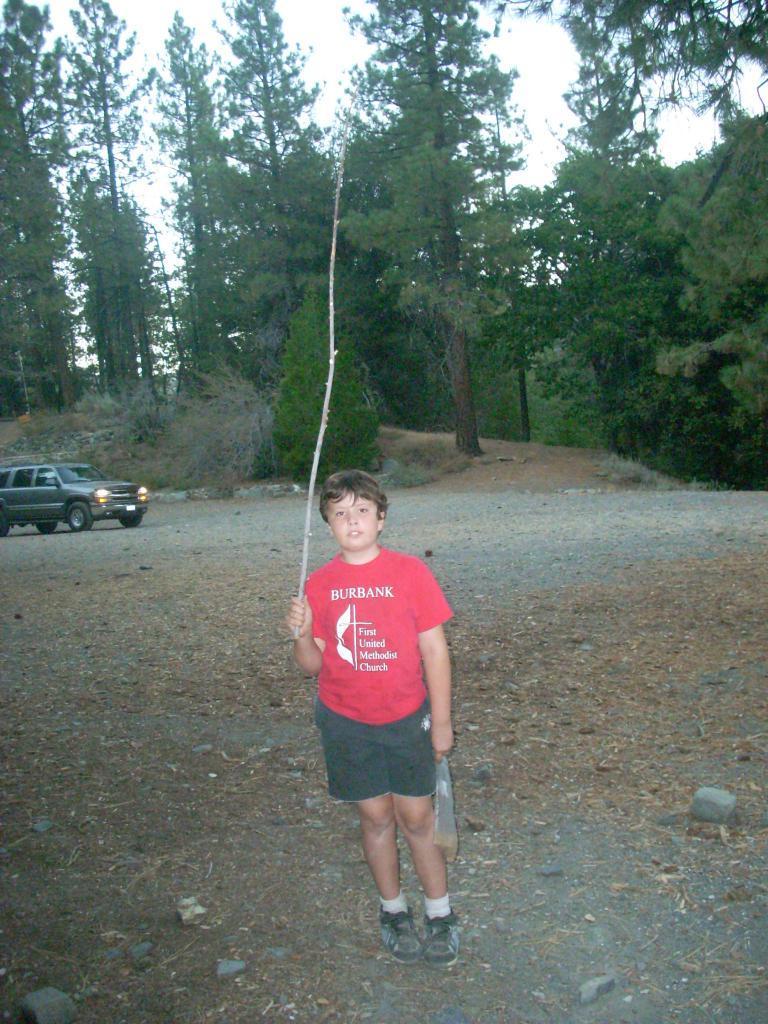Could you give a brief overview of what you see in this image? In this picture there is a boy standing and holding stick and object. We can see stones, car, trees and ground. In the background of the image we can see the sky. 